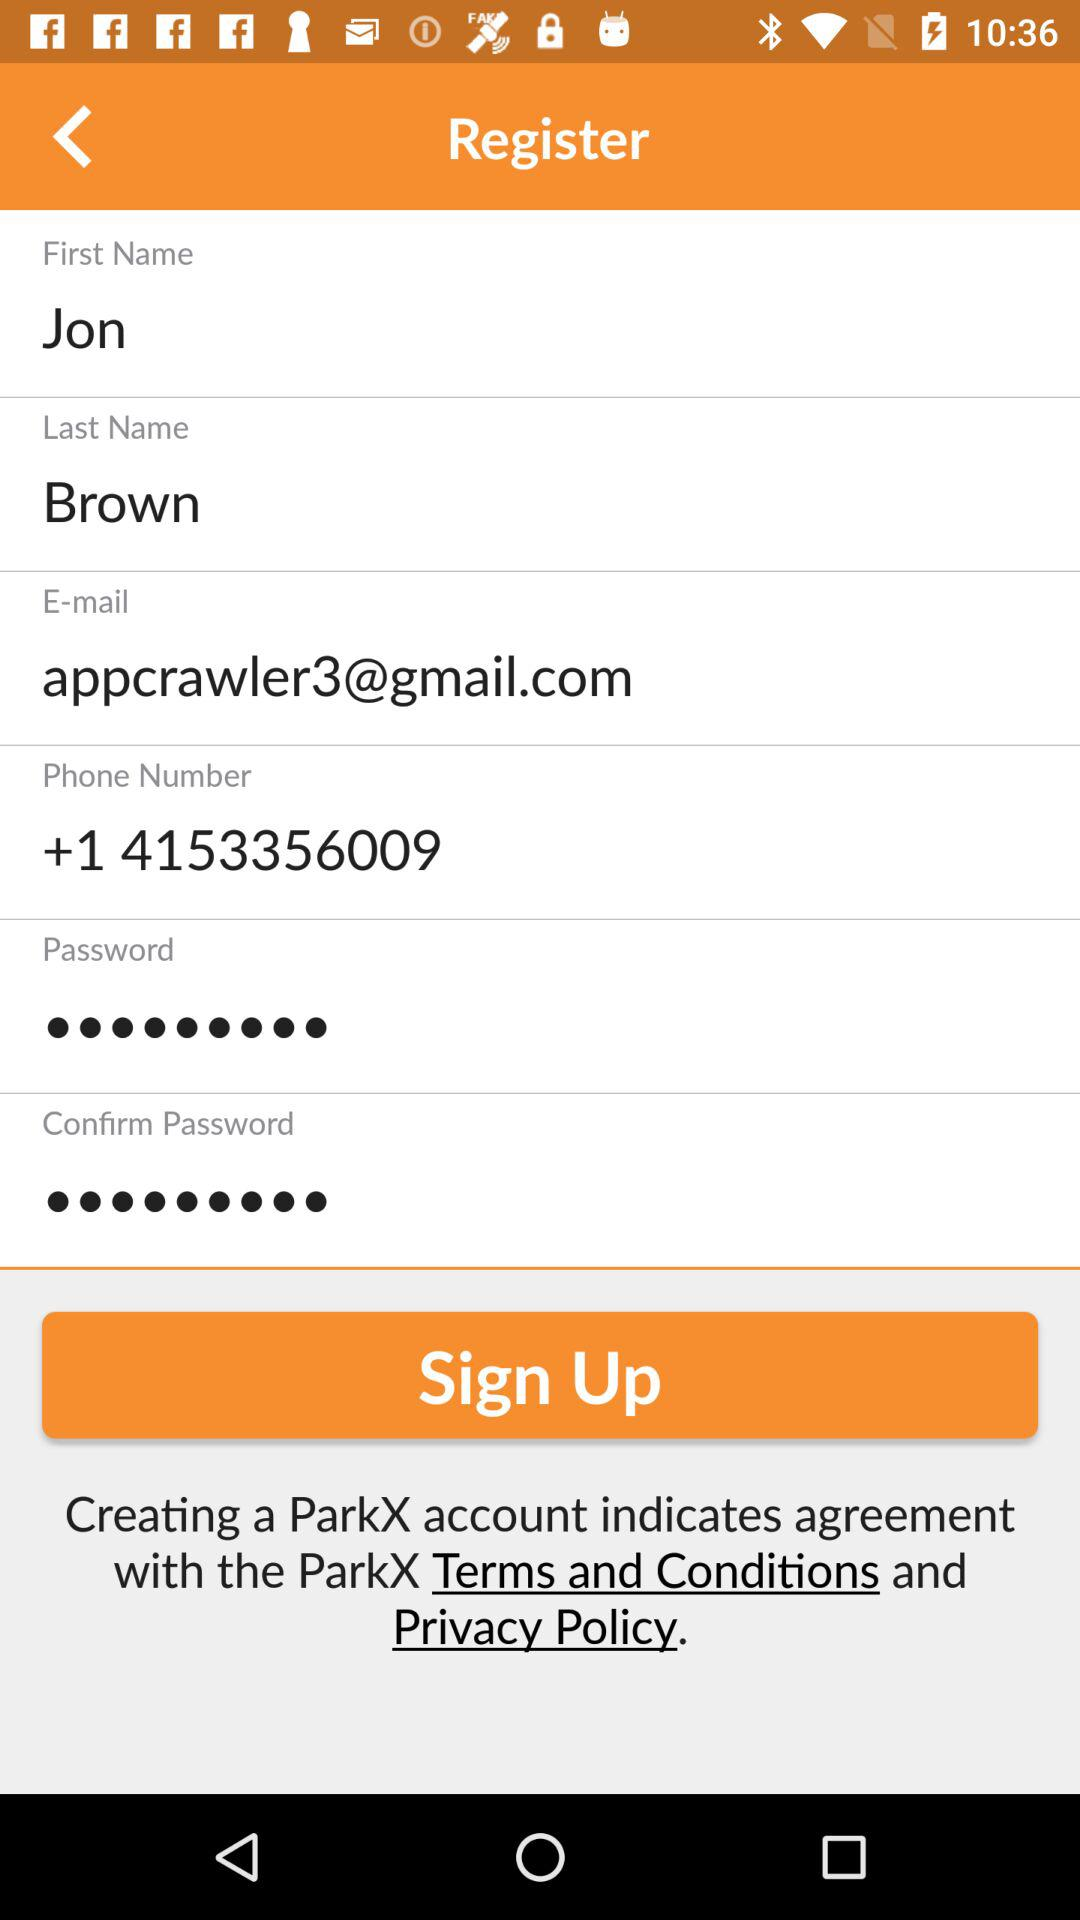What name is displayed? The displayed name is "Jon Brown". 